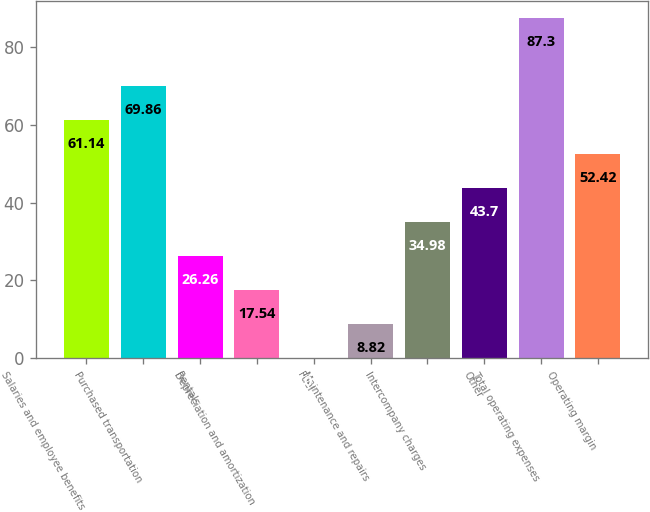<chart> <loc_0><loc_0><loc_500><loc_500><bar_chart><fcel>Salaries and employee benefits<fcel>Purchased transportation<fcel>Rentals<fcel>Depreciation and amortization<fcel>Fuel<fcel>Maintenance and repairs<fcel>Intercompany charges<fcel>Other<fcel>Total operating expenses<fcel>Operating margin<nl><fcel>61.14<fcel>69.86<fcel>26.26<fcel>17.54<fcel>0.1<fcel>8.82<fcel>34.98<fcel>43.7<fcel>87.3<fcel>52.42<nl></chart> 